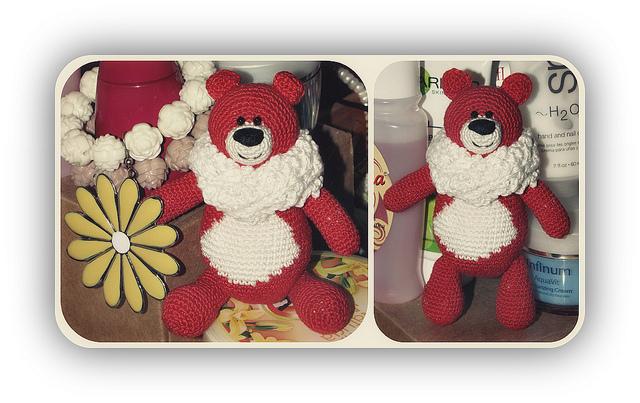What color are the teddy bears?
Keep it brief. Red. Does the bear have a scarf?
Short answer required. Yes. What color is this bear?
Keep it brief. Red and white. What's probably inside the case?
Concise answer only. Bear. 